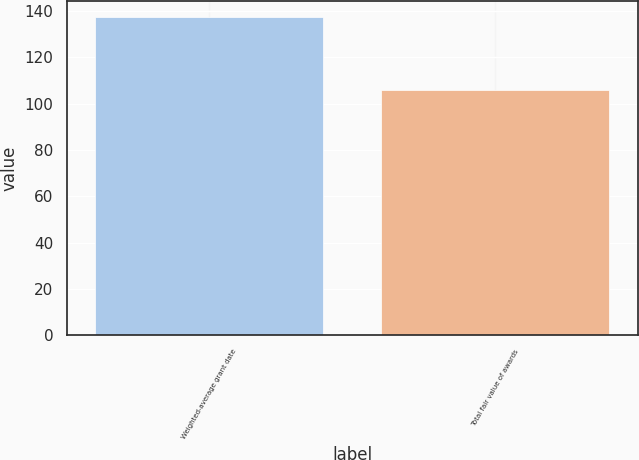Convert chart. <chart><loc_0><loc_0><loc_500><loc_500><bar_chart><fcel>Weighted-average grant date<fcel>Total fair value of awards<nl><fcel>137.45<fcel>106<nl></chart> 